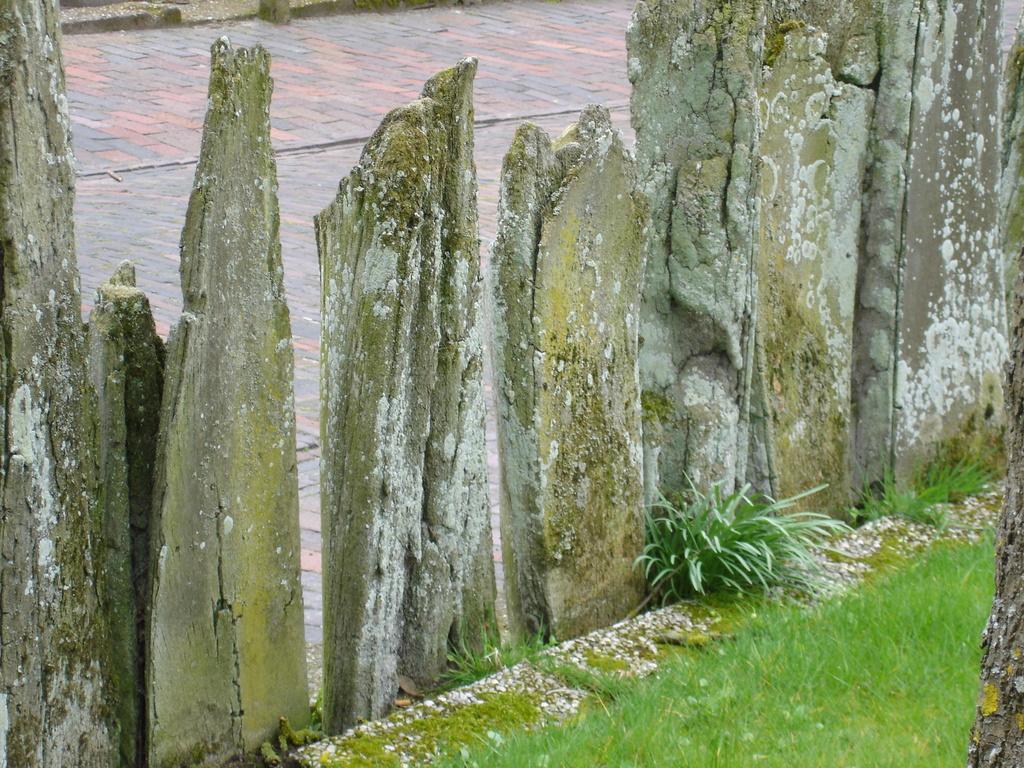Can you describe this image briefly? In this image we can see the stones. And there is a grass, plants and ground. 